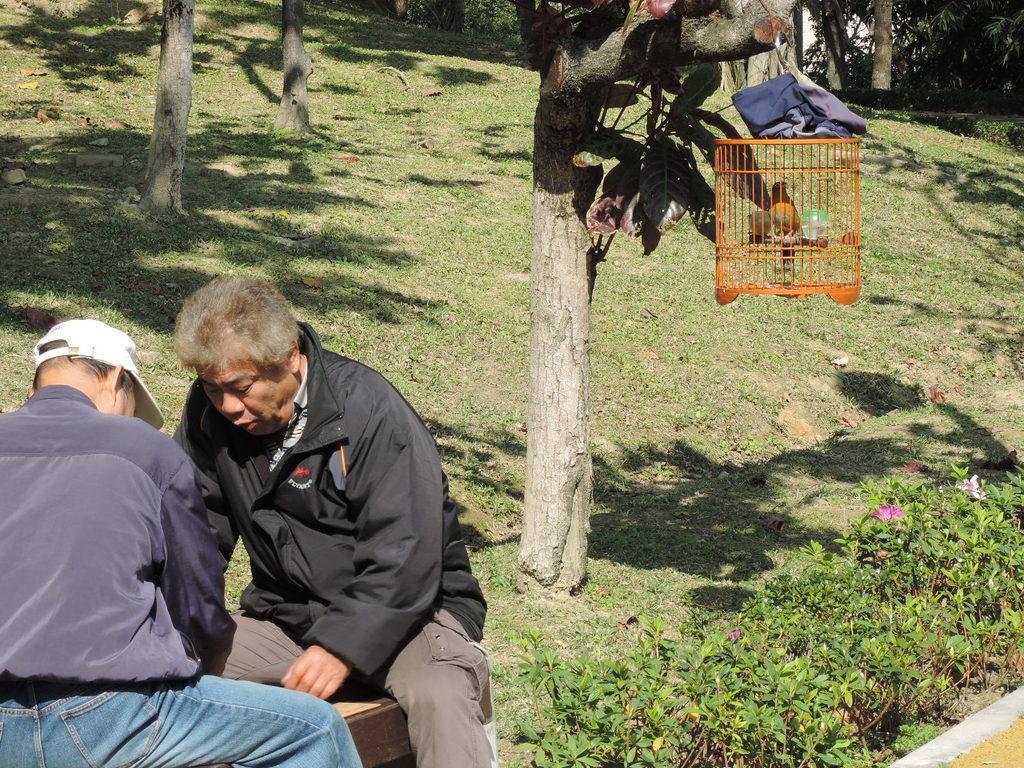In one or two sentences, can you explain what this image depicts? In this image on the left there is a man, he wears a black jacket, trouser, he is sitting, in front of there is a man, he wears a black jacket, trouser and cap. In the middle there are plants, flowers, trees, bird, case, cloth, trees and grass. 